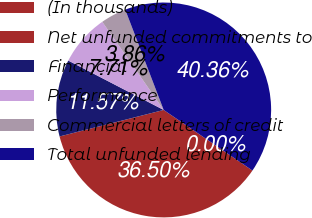Convert chart to OTSL. <chart><loc_0><loc_0><loc_500><loc_500><pie_chart><fcel>(In thousands)<fcel>Net unfunded commitments to<fcel>Financial<fcel>Performance<fcel>Commercial letters of credit<fcel>Total unfunded lending<nl><fcel>0.0%<fcel>36.5%<fcel>11.57%<fcel>7.71%<fcel>3.86%<fcel>40.36%<nl></chart> 